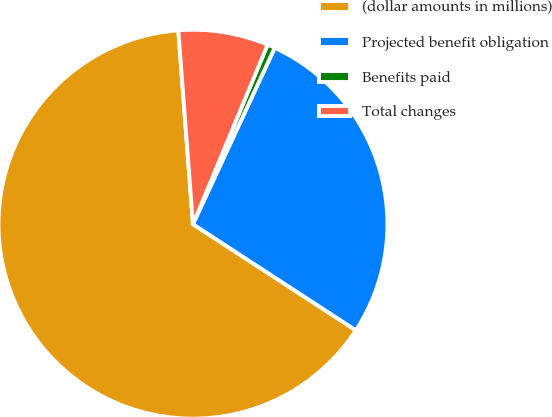<chart> <loc_0><loc_0><loc_500><loc_500><pie_chart><fcel>(dollar amounts in millions)<fcel>Projected benefit obligation<fcel>Benefits paid<fcel>Total changes<nl><fcel>64.62%<fcel>27.28%<fcel>0.64%<fcel>7.47%<nl></chart> 